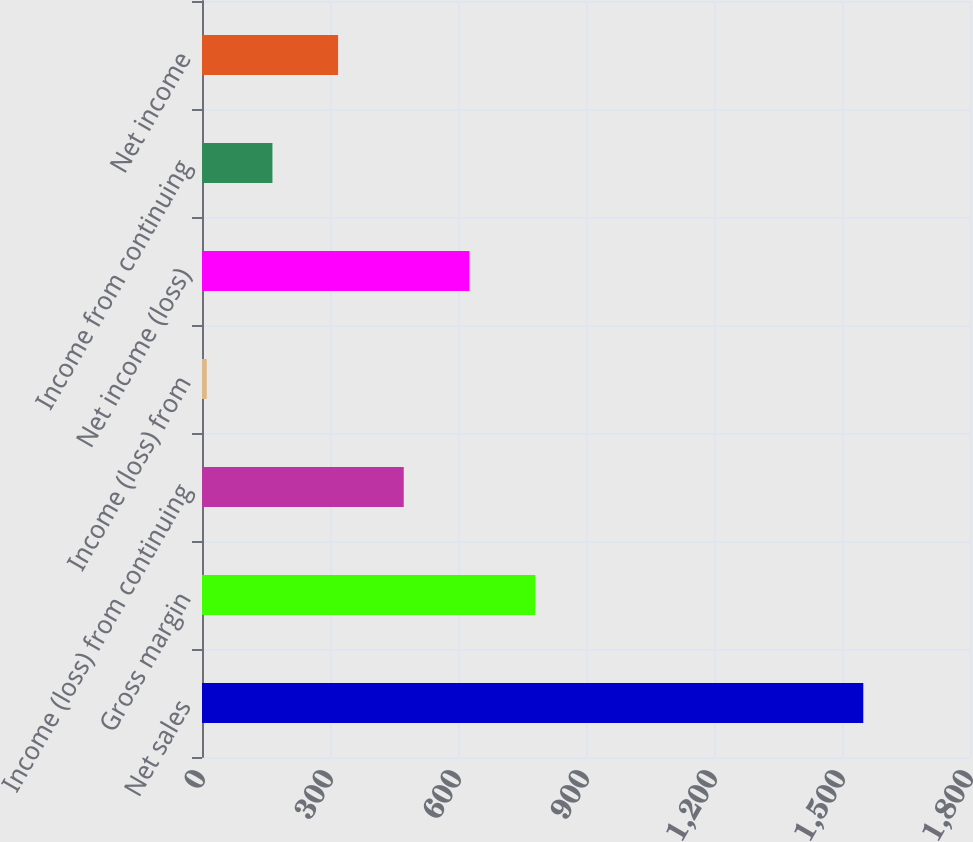Convert chart. <chart><loc_0><loc_0><loc_500><loc_500><bar_chart><fcel>Net sales<fcel>Gross margin<fcel>Income (loss) from continuing<fcel>Income (loss) from<fcel>Net income (loss)<fcel>Income from continuing<fcel>Net income<nl><fcel>1549.9<fcel>780.55<fcel>472.81<fcel>11.2<fcel>626.68<fcel>165.07<fcel>318.94<nl></chart> 